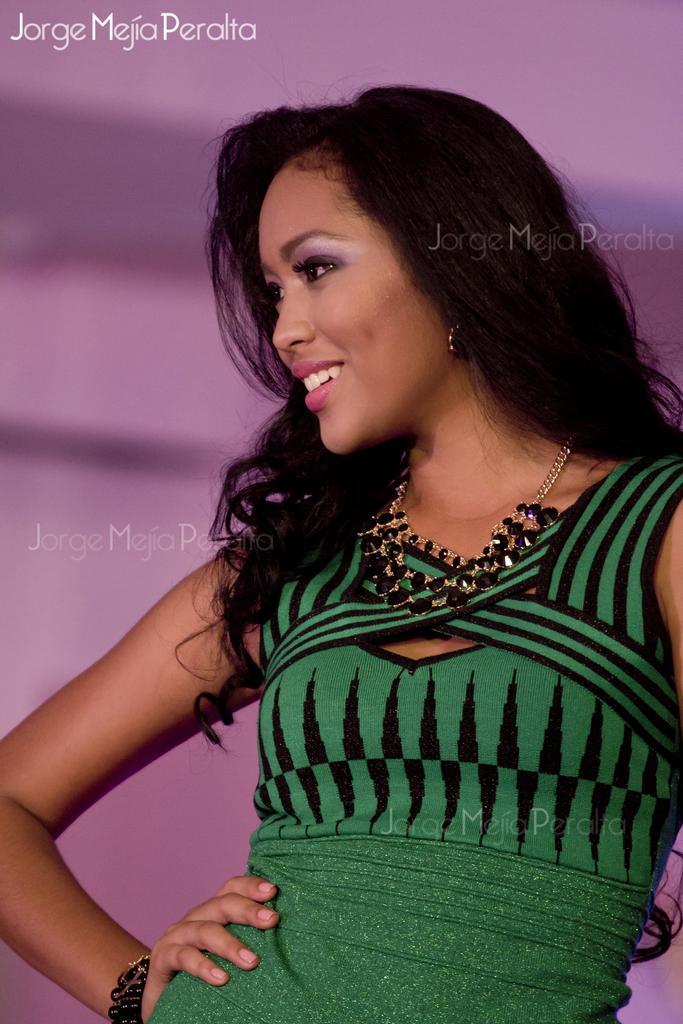In one or two sentences, can you explain what this image depicts? In this image we can see a woman is standing. In the background the image is blur and we can see texts written on the image. 